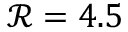<formula> <loc_0><loc_0><loc_500><loc_500>\mathcal { R } = 4 . 5</formula> 